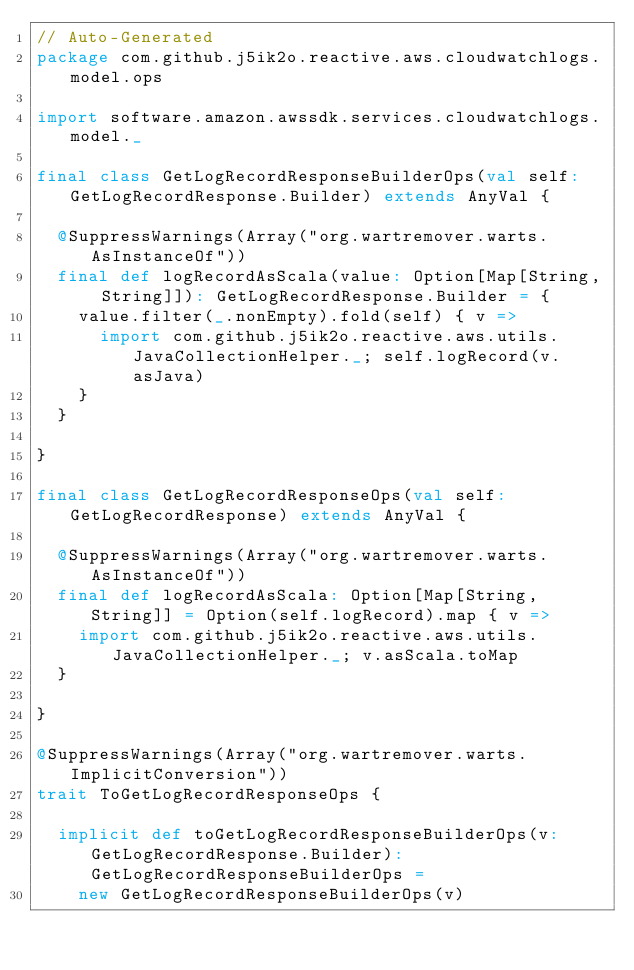Convert code to text. <code><loc_0><loc_0><loc_500><loc_500><_Scala_>// Auto-Generated
package com.github.j5ik2o.reactive.aws.cloudwatchlogs.model.ops

import software.amazon.awssdk.services.cloudwatchlogs.model._

final class GetLogRecordResponseBuilderOps(val self: GetLogRecordResponse.Builder) extends AnyVal {

  @SuppressWarnings(Array("org.wartremover.warts.AsInstanceOf"))
  final def logRecordAsScala(value: Option[Map[String, String]]): GetLogRecordResponse.Builder = {
    value.filter(_.nonEmpty).fold(self) { v =>
      import com.github.j5ik2o.reactive.aws.utils.JavaCollectionHelper._; self.logRecord(v.asJava)
    }
  }

}

final class GetLogRecordResponseOps(val self: GetLogRecordResponse) extends AnyVal {

  @SuppressWarnings(Array("org.wartremover.warts.AsInstanceOf"))
  final def logRecordAsScala: Option[Map[String, String]] = Option(self.logRecord).map { v =>
    import com.github.j5ik2o.reactive.aws.utils.JavaCollectionHelper._; v.asScala.toMap
  }

}

@SuppressWarnings(Array("org.wartremover.warts.ImplicitConversion"))
trait ToGetLogRecordResponseOps {

  implicit def toGetLogRecordResponseBuilderOps(v: GetLogRecordResponse.Builder): GetLogRecordResponseBuilderOps =
    new GetLogRecordResponseBuilderOps(v)
</code> 